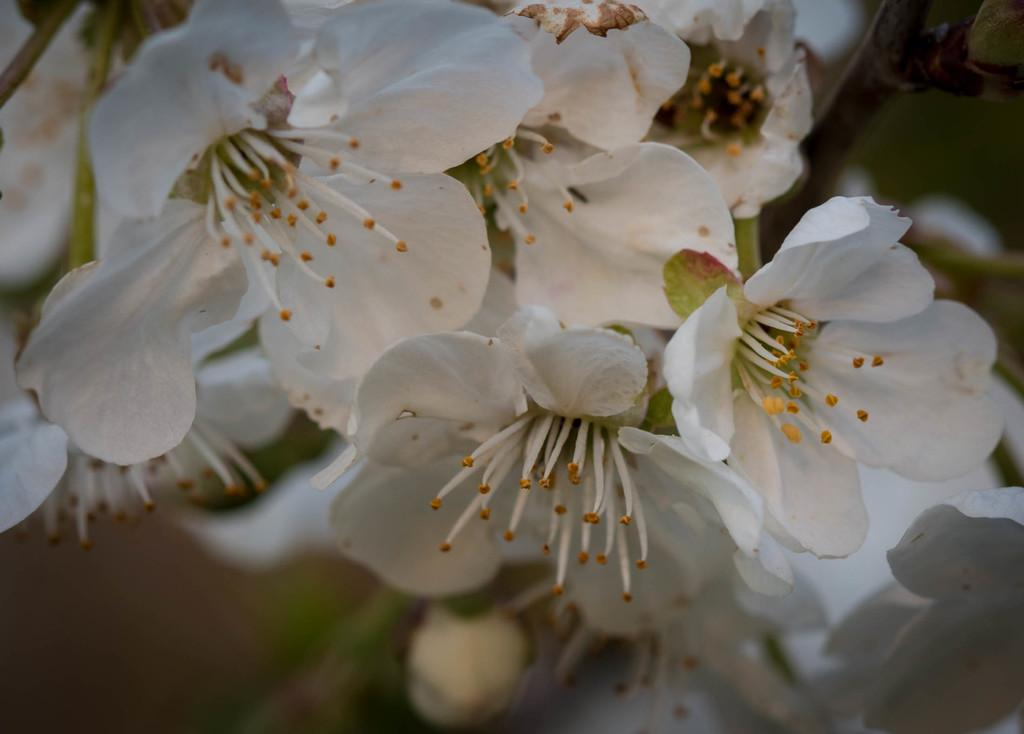What type of living organisms can be seen in the image? There are flowers in the image. What type of idea is depicted by the scarecrow in the image? There is no scarecrow present in the image; it only features flowers. 